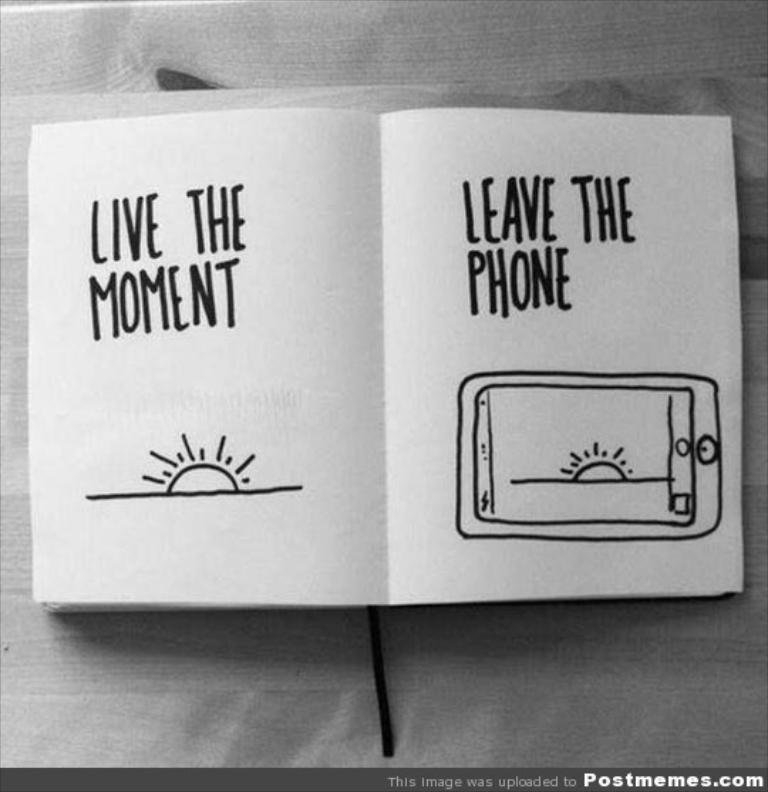Can you describe this image briefly? This is a black and white image. In the center of the image there is a book with some text on it on the table. 